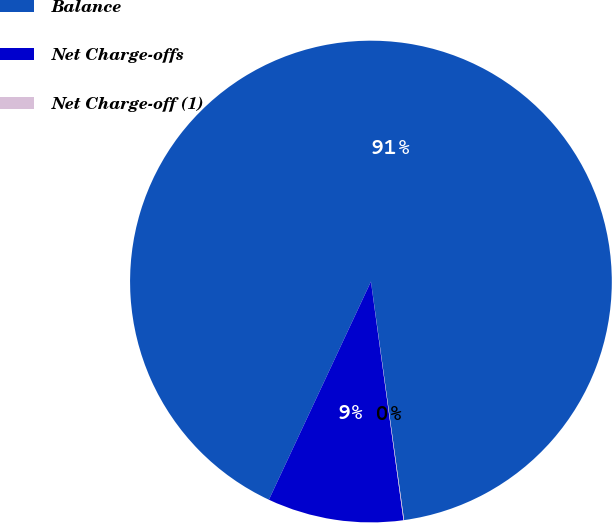<chart> <loc_0><loc_0><loc_500><loc_500><pie_chart><fcel>Balance<fcel>Net Charge-offs<fcel>Net Charge-off (1)<nl><fcel>90.85%<fcel>9.12%<fcel>0.04%<nl></chart> 